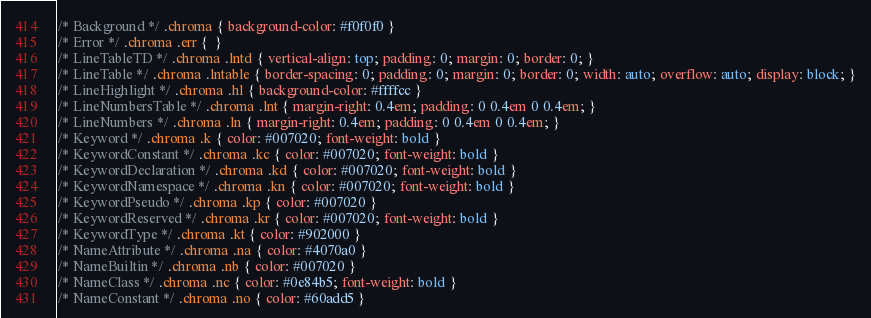<code> <loc_0><loc_0><loc_500><loc_500><_CSS_>/* Background */ .chroma { background-color: #f0f0f0 }
/* Error */ .chroma .err {  }
/* LineTableTD */ .chroma .lntd { vertical-align: top; padding: 0; margin: 0; border: 0; }
/* LineTable */ .chroma .lntable { border-spacing: 0; padding: 0; margin: 0; border: 0; width: auto; overflow: auto; display: block; }
/* LineHighlight */ .chroma .hl { background-color: #ffffcc }
/* LineNumbersTable */ .chroma .lnt { margin-right: 0.4em; padding: 0 0.4em 0 0.4em; }
/* LineNumbers */ .chroma .ln { margin-right: 0.4em; padding: 0 0.4em 0 0.4em; }
/* Keyword */ .chroma .k { color: #007020; font-weight: bold }
/* KeywordConstant */ .chroma .kc { color: #007020; font-weight: bold }
/* KeywordDeclaration */ .chroma .kd { color: #007020; font-weight: bold }
/* KeywordNamespace */ .chroma .kn { color: #007020; font-weight: bold }
/* KeywordPseudo */ .chroma .kp { color: #007020 }
/* KeywordReserved */ .chroma .kr { color: #007020; font-weight: bold }
/* KeywordType */ .chroma .kt { color: #902000 }
/* NameAttribute */ .chroma .na { color: #4070a0 }
/* NameBuiltin */ .chroma .nb { color: #007020 }
/* NameClass */ .chroma .nc { color: #0e84b5; font-weight: bold }
/* NameConstant */ .chroma .no { color: #60add5 }</code> 